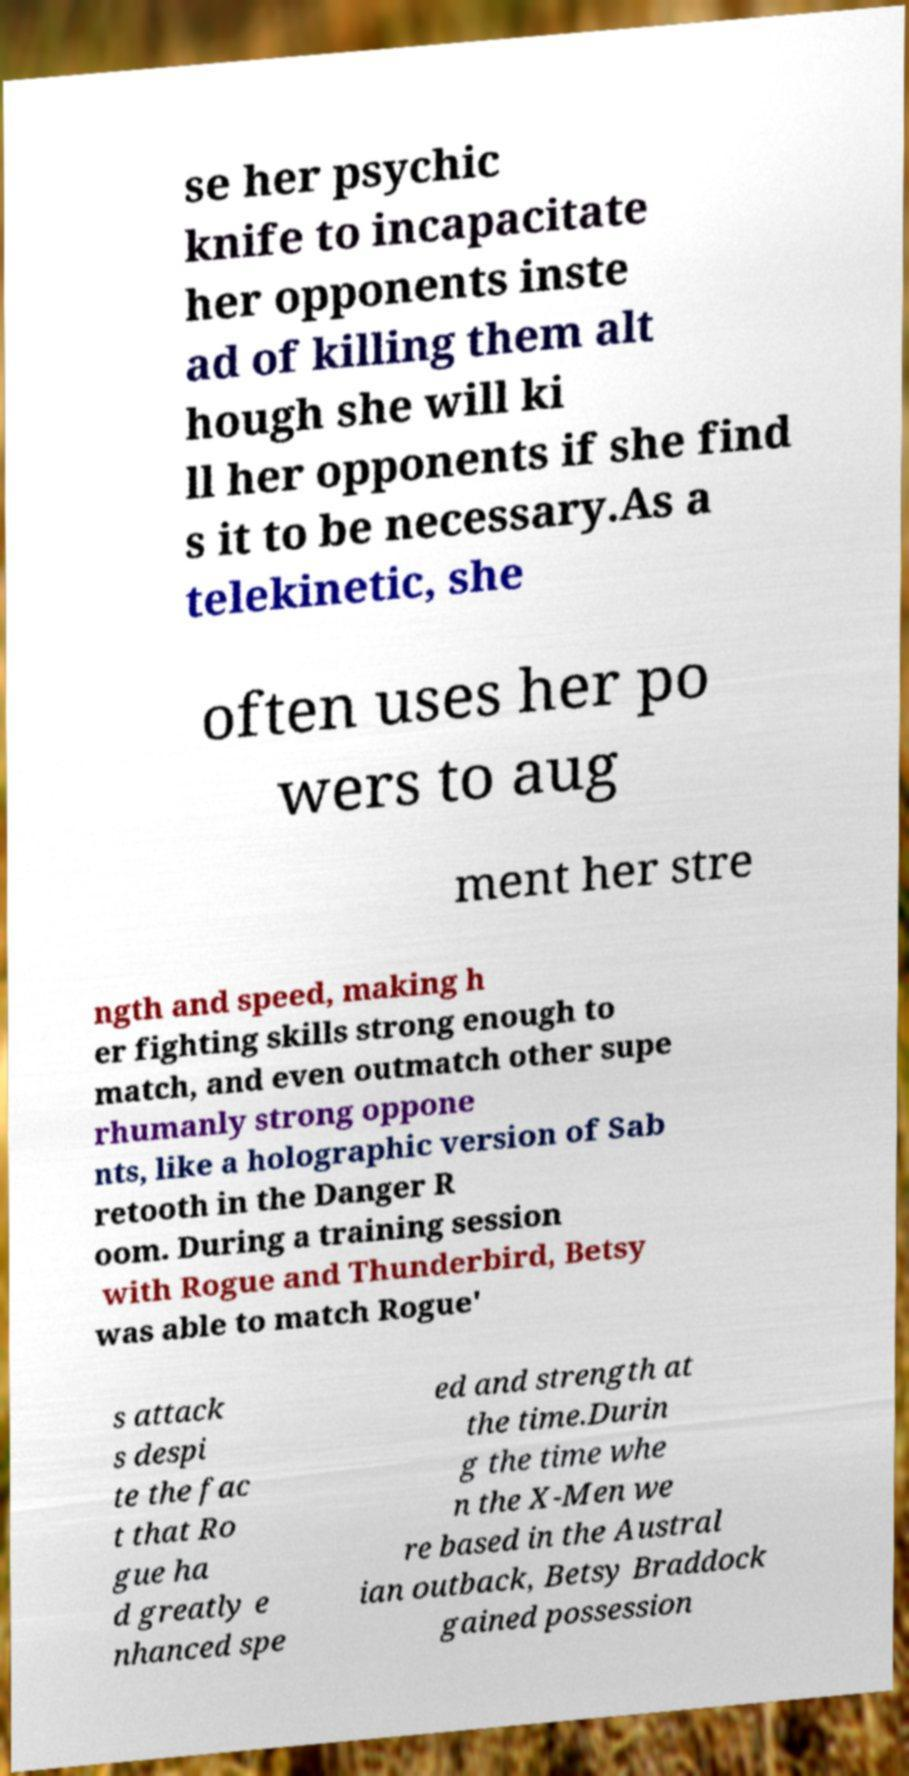Please read and relay the text visible in this image. What does it say? se her psychic knife to incapacitate her opponents inste ad of killing them alt hough she will ki ll her opponents if she find s it to be necessary.As a telekinetic, she often uses her po wers to aug ment her stre ngth and speed, making h er fighting skills strong enough to match, and even outmatch other supe rhumanly strong oppone nts, like a holographic version of Sab retooth in the Danger R oom. During a training session with Rogue and Thunderbird, Betsy was able to match Rogue' s attack s despi te the fac t that Ro gue ha d greatly e nhanced spe ed and strength at the time.Durin g the time whe n the X-Men we re based in the Austral ian outback, Betsy Braddock gained possession 